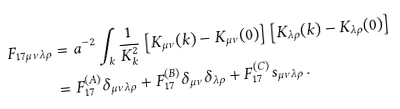<formula> <loc_0><loc_0><loc_500><loc_500>F _ { 1 7 \mu \nu \lambda \rho } & = a ^ { - 2 } \int _ { k } \frac { 1 } { K _ { k } ^ { 2 } } \left [ K _ { \mu \nu } ( k ) - K _ { \mu \nu } ( 0 ) \right ] \left [ K _ { \lambda \rho } ( k ) - K _ { \lambda \rho } ( 0 ) \right ] \\ & = F _ { 1 7 } ^ { ( A ) } \delta _ { \mu \nu \lambda \rho } + F _ { 1 7 } ^ { ( B ) } \delta _ { \mu \nu } \delta _ { \lambda \rho } + F _ { 1 7 } ^ { ( C ) } s _ { \mu \nu \lambda \rho } \, .</formula> 